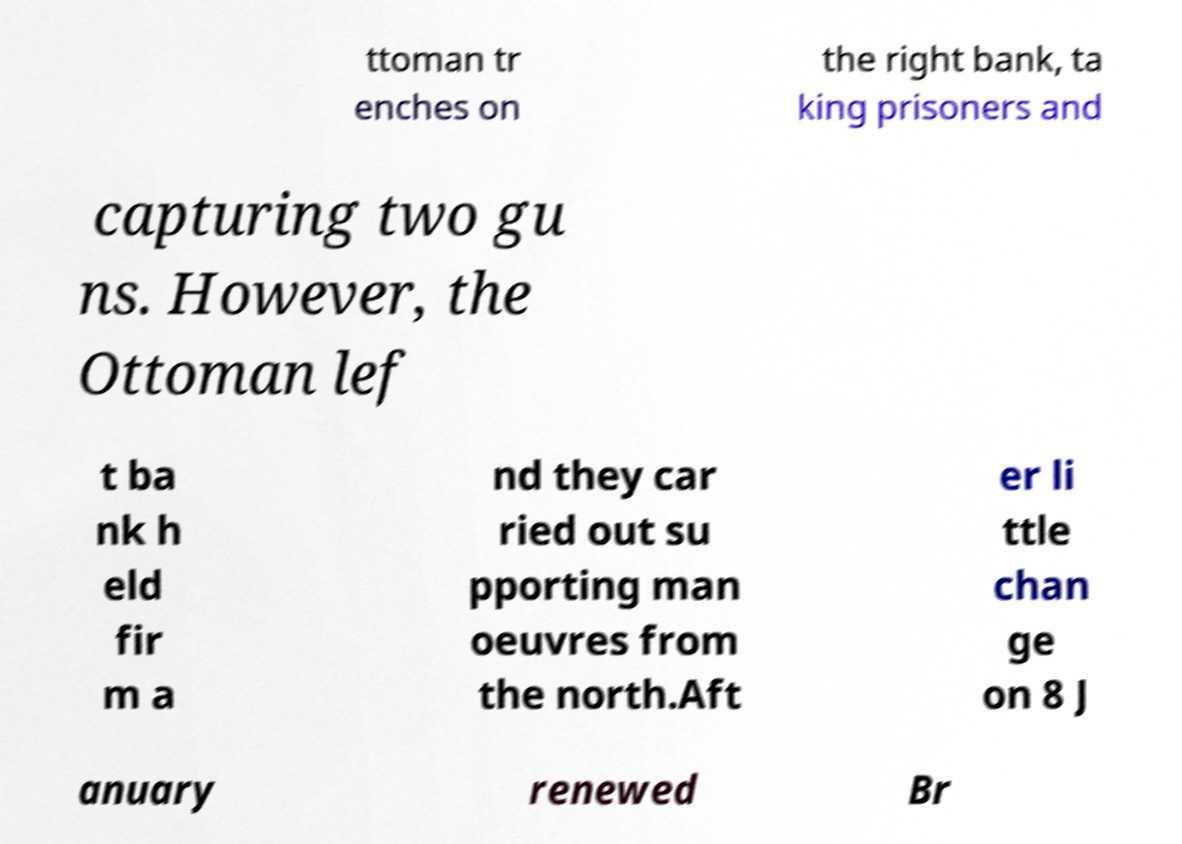For documentation purposes, I need the text within this image transcribed. Could you provide that? ttoman tr enches on the right bank, ta king prisoners and capturing two gu ns. However, the Ottoman lef t ba nk h eld fir m a nd they car ried out su pporting man oeuvres from the north.Aft er li ttle chan ge on 8 J anuary renewed Br 